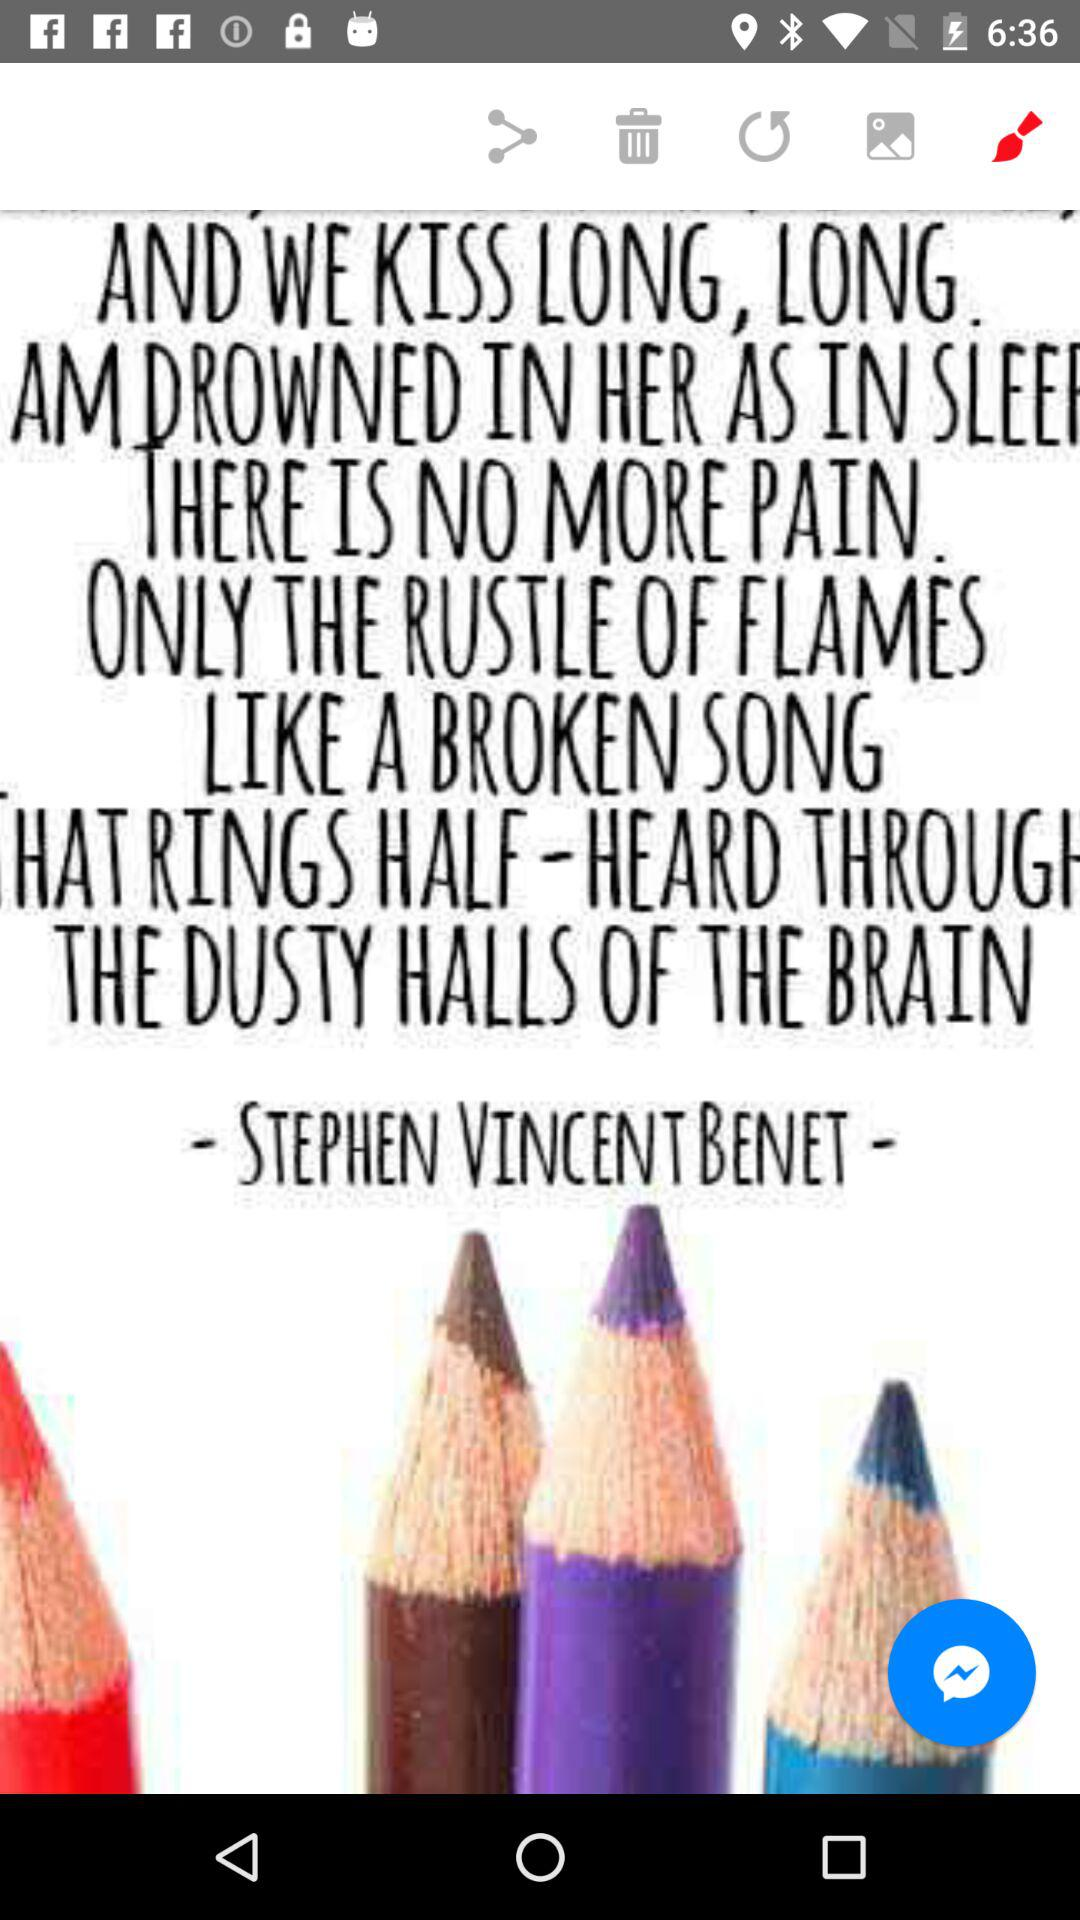Who is the writer? The writer is "STEPHEN VINCENT BENET". 